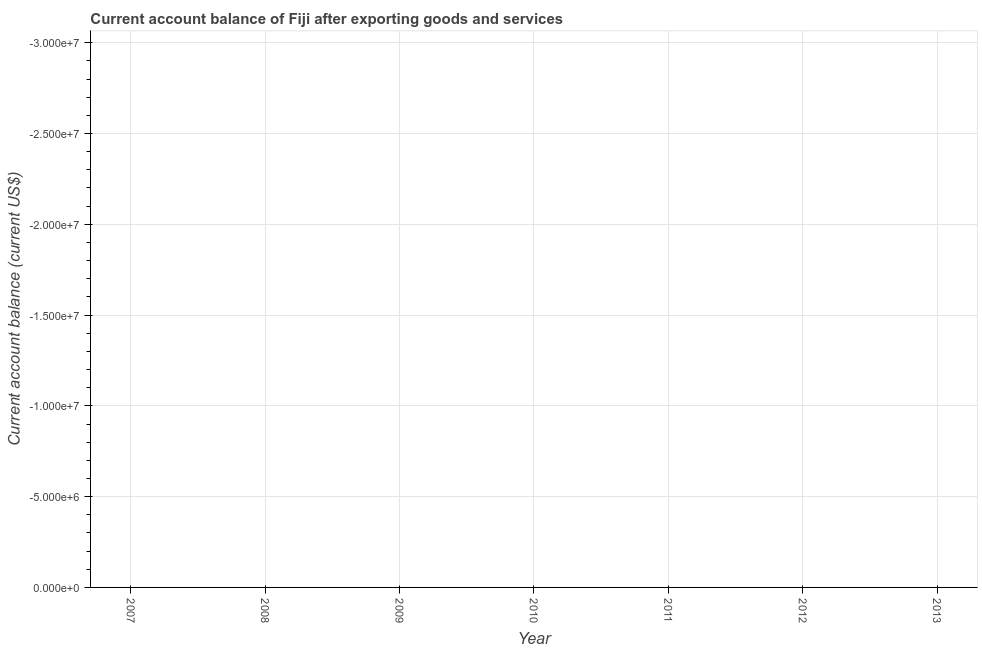What is the current account balance in 2009?
Your answer should be compact. 0. What is the average current account balance per year?
Ensure brevity in your answer.  0. What is the median current account balance?
Offer a terse response. 0. In how many years, is the current account balance greater than -18000000 US$?
Provide a short and direct response. 0. In how many years, is the current account balance greater than the average current account balance taken over all years?
Your response must be concise. 0. Are the values on the major ticks of Y-axis written in scientific E-notation?
Your answer should be compact. Yes. Does the graph contain any zero values?
Your answer should be compact. Yes. What is the title of the graph?
Your answer should be compact. Current account balance of Fiji after exporting goods and services. What is the label or title of the X-axis?
Give a very brief answer. Year. What is the label or title of the Y-axis?
Your answer should be very brief. Current account balance (current US$). What is the Current account balance (current US$) in 2008?
Your answer should be compact. 0. What is the Current account balance (current US$) in 2009?
Your answer should be compact. 0. What is the Current account balance (current US$) in 2011?
Keep it short and to the point. 0. 